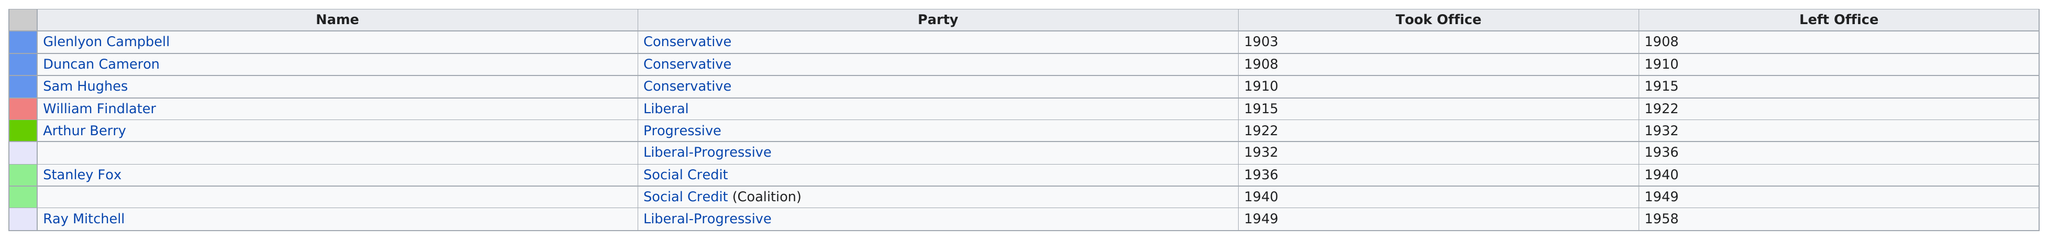Indicate a few pertinent items in this graphic. William Findlater is a representative in the Liberal Party who took office for a term of seven years. Arthur Berry, a member of the progressive party, took office after a liberal. Before Arthur Berry was the Provincial Representative for Gilbert Plains, the position was held by William Findlater. William Findlater was the only liberal candidate to be elected and take office. Gilbert Plains has had a total of three conservative provincial representatives. 